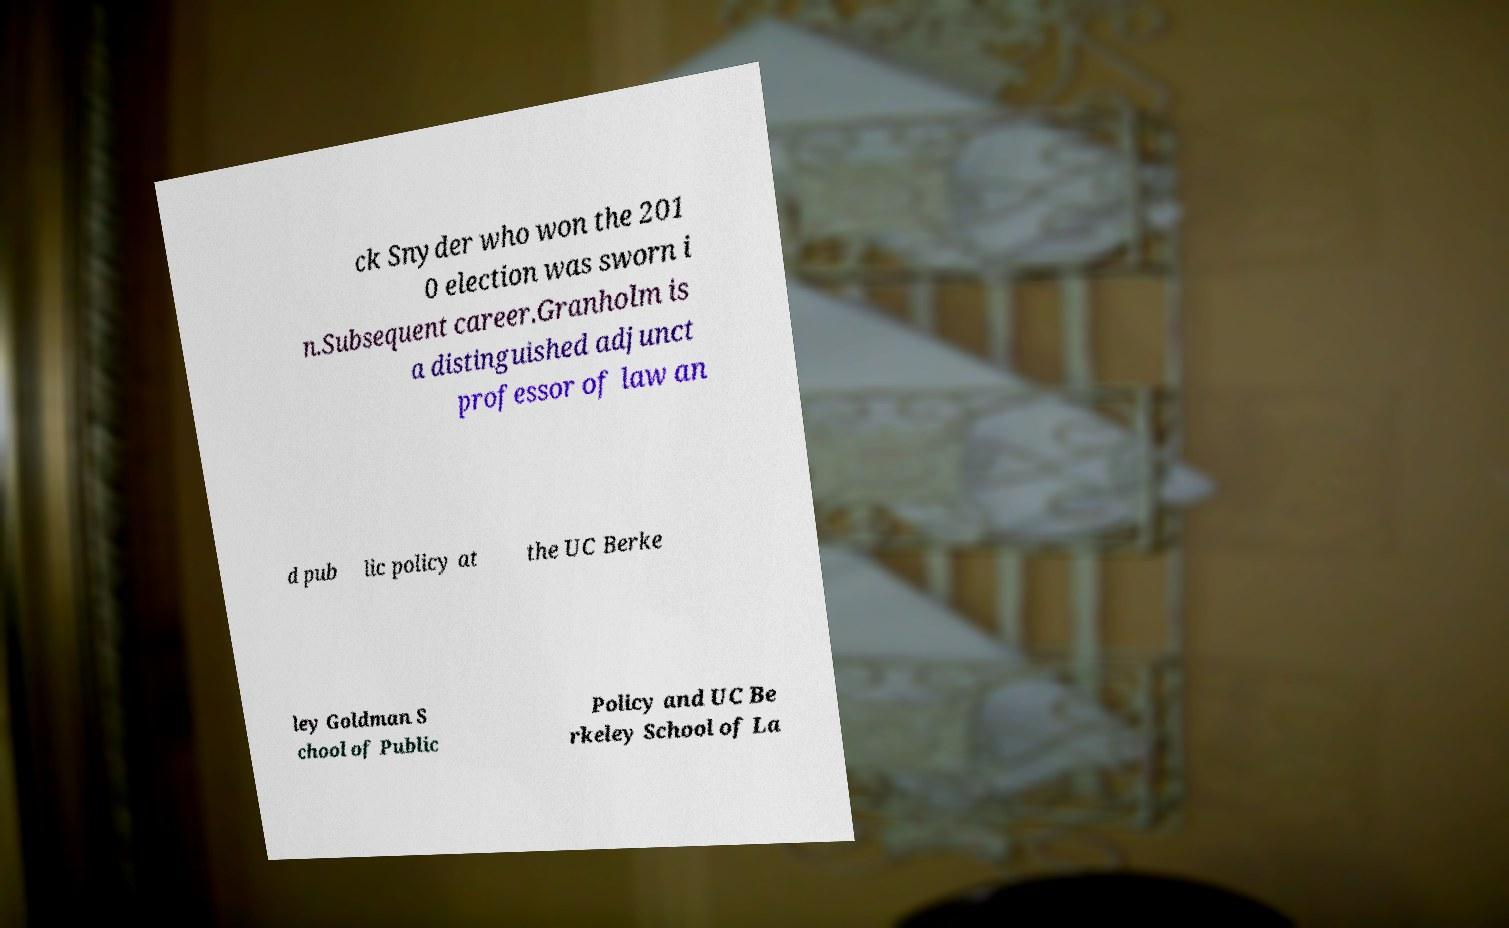For documentation purposes, I need the text within this image transcribed. Could you provide that? ck Snyder who won the 201 0 election was sworn i n.Subsequent career.Granholm is a distinguished adjunct professor of law an d pub lic policy at the UC Berke ley Goldman S chool of Public Policy and UC Be rkeley School of La 